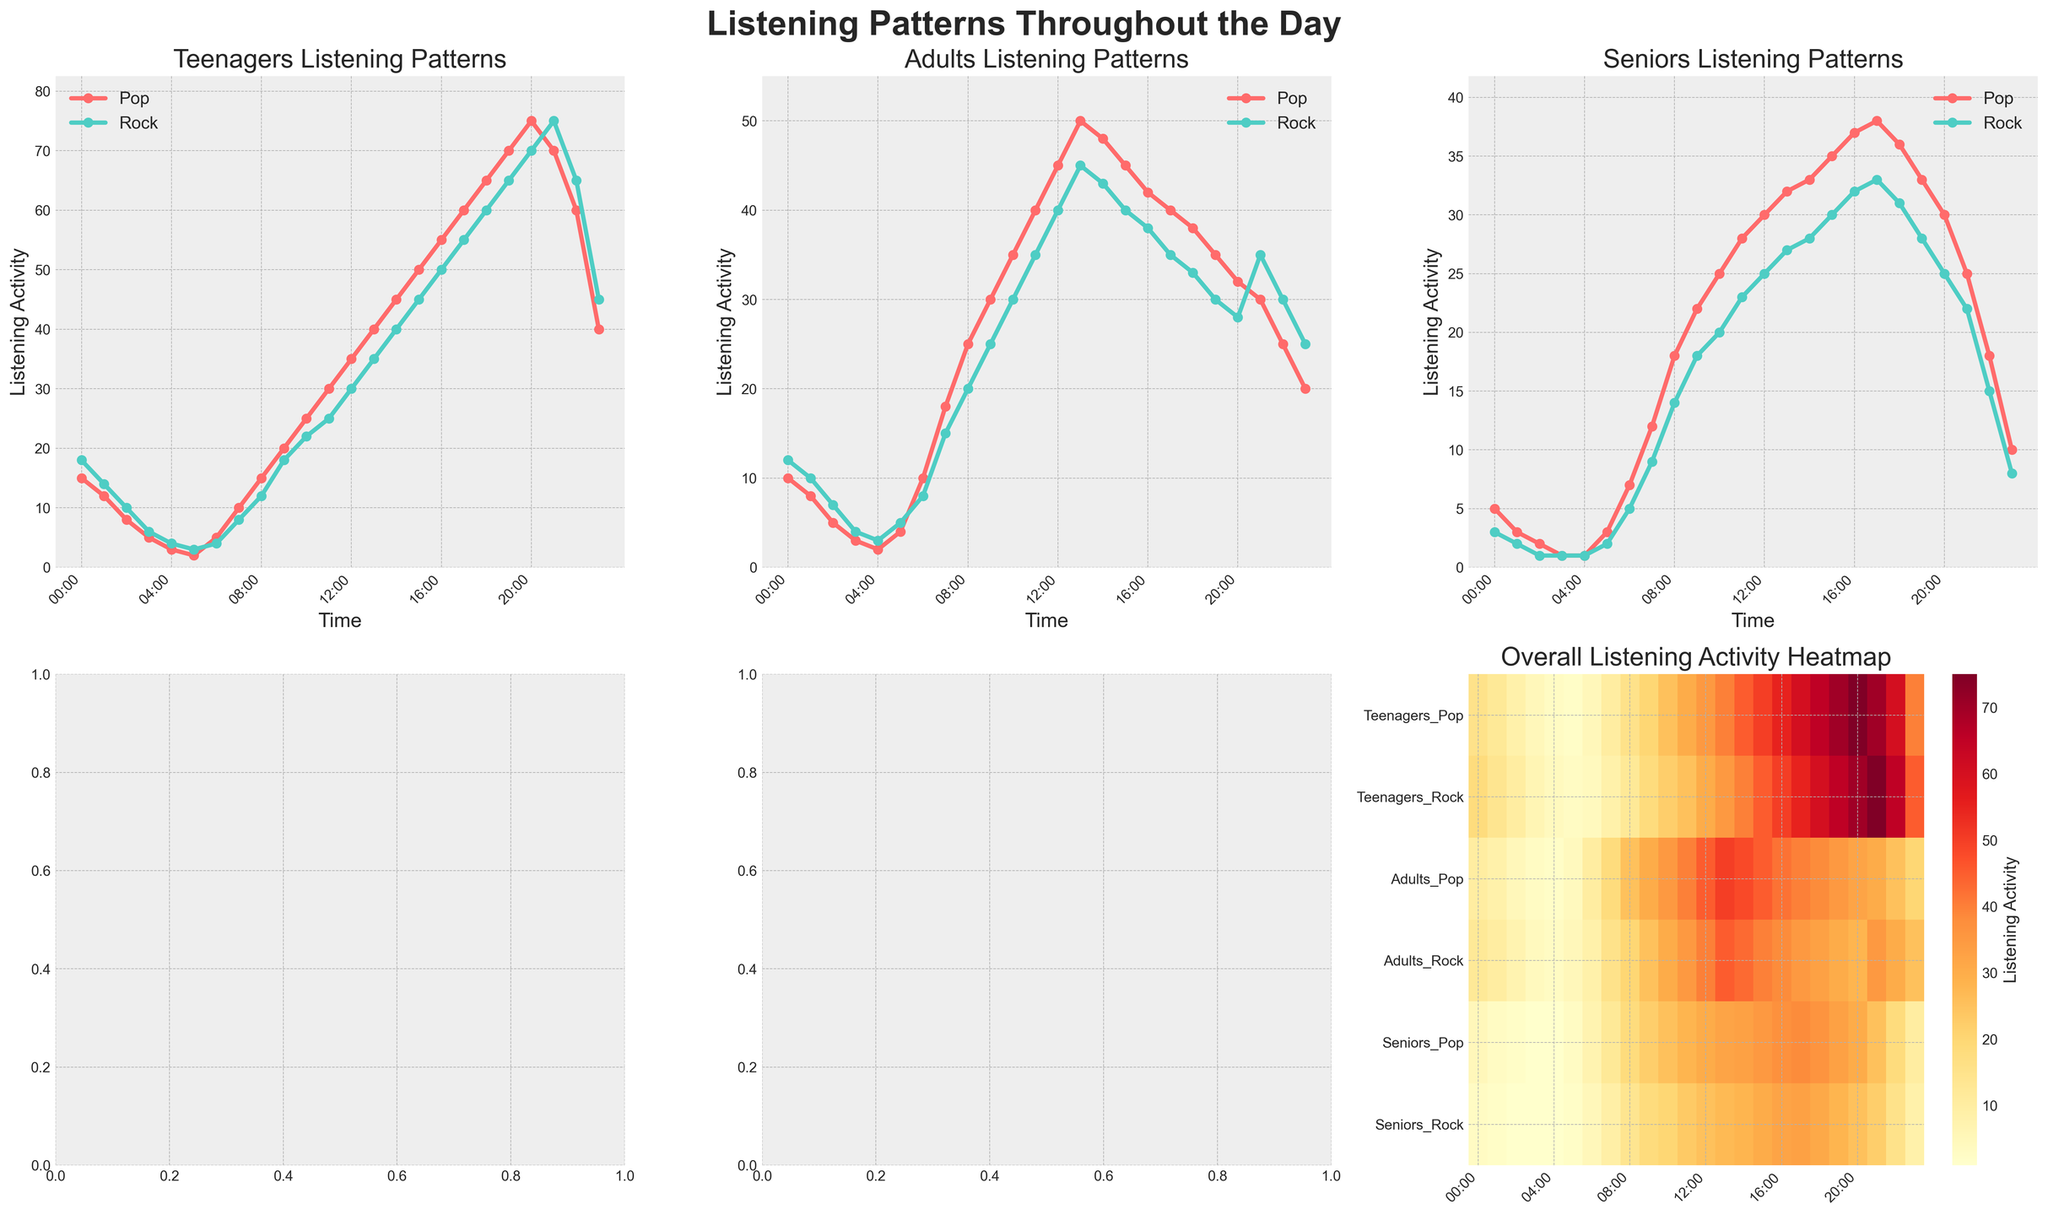What time do Teenagers' listening patterns for Pop reach their peak? Teenagers' Pop listening pattern reaches its highest point as indicated by the maximum height of the red line on the "Teenagers Listening Patterns" subplot. Referring to the red line, it peaks at 75 at 20:00.
Answer: 20:00 Which demographic shows the earliest peak in Rock listening patterns, and at what time? Comparing the Rock listening patterns across all demographics on their respective subplots, Seniors peak earliest at 13:00 followed by Teenagers at 21:00 and Adults who have a generally consistent pattern with no clear major peak.
Answer: Seniors at 13:00 Between 08:00 and 12:00, which demographic has a higher average listening activity for Pop? Calculate the average listening activity for Pop from 08:00 to 12:00 for each demographic. Teenagers: (15+20+25+30+35)/5 = 25, Adults: (25+30+35+40+45)/5 = 35, Seniors: (18+22+25+28+30)/5 = 24. Therefore, Adults have the highest average at 35.
Answer: Adults How does the listening activity of Seniors at 22:00 compare between Pop and Rock? Refer to the "Seniors Listening Patterns" subplot at the 22:00 time mark. Compare the values of the yellow line (Pop) and teal line (Rock). Seniors' Pop activity is 18, while Rock is 15.
Answer: Pop is higher At what time do Adults have the lowest listening activity for Pop, and what is the value? Refer to the "Adults Listening Patterns" subplot. Identify the minimum point of the red line (Pop). The lowest value is 8 at 01:00.
Answer: 01:00, 8 What is the difference between Teenagers' Rock listening activity and Seniors' Rock listening activity at 11:00? Refer to the data or "Teenagers Listening Patterns" and "Seniors Listening Patterns" for 11:00. Teenagers' Rock is 25, and Seniors' Rock is 23. The difference is 25 - 23.
Answer: 2 Which genre shows a higher peak in listening activity among Teenagers, and what is the value? Compare the peaks of the red and teal lines on the "Teenagers Listening Patterns" subplot. The highest value for Pop is 75 and for Rock is 75. Both genres have the same peak value.
Answer: Both, 75 In the heatmap, which genre and demographic combination shows a sudden increase toward the evening hours? Look at the heatmap's color intensity changes. Teenagers' Rock (second row) shows a significant increase towards the evening, becoming very prominent from around 17:00 to 21:00.
Answer: Teenagers' Rock On the overall heatmap, identify the time interval where the listening activity of all demographics combined appears to be highest. Examine the heatmap, looking for the brightest horizontal bands representing high activity levels. This band is most prominent from 13:00 to 17:00.
Answer: 13:00 to 17:00 Which demographic experiences the highest variability in Pop listening activity throughout the day? Compare the amplitude of the red lines across all demographic subplots. Teenagers show the highest variability with Pop listening jumping from 2 to 75 in one day.
Answer: Teenagers 